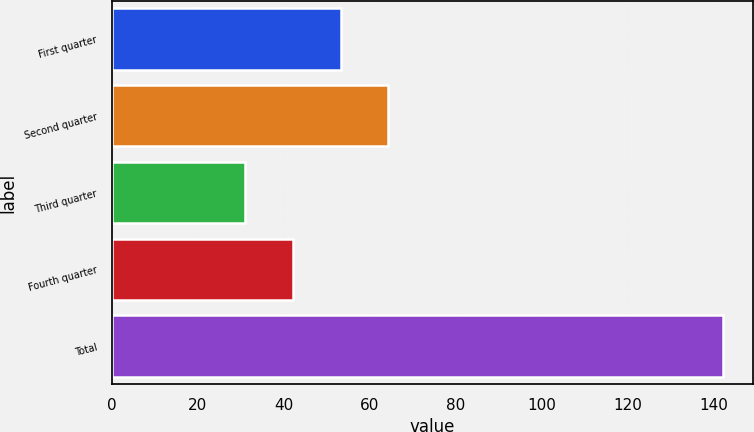Convert chart. <chart><loc_0><loc_0><loc_500><loc_500><bar_chart><fcel>First quarter<fcel>Second quarter<fcel>Third quarter<fcel>Fourth quarter<fcel>Total<nl><fcel>53.2<fcel>64.3<fcel>31<fcel>42.1<fcel>142<nl></chart> 